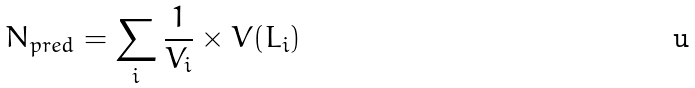<formula> <loc_0><loc_0><loc_500><loc_500>N _ { p r e d } = \sum _ { i } \frac { 1 } { V _ { i } } \times V ( L _ { i } )</formula> 